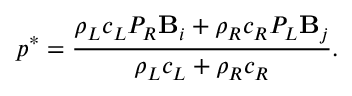Convert formula to latex. <formula><loc_0><loc_0><loc_500><loc_500>p ^ { * } = \frac { \rho _ { L } c _ { L } P _ { R } B _ { i } + \rho _ { R } c _ { R } P _ { L } B _ { j } } { \rho _ { L } c _ { L } + \rho _ { R } c _ { R } } .</formula> 